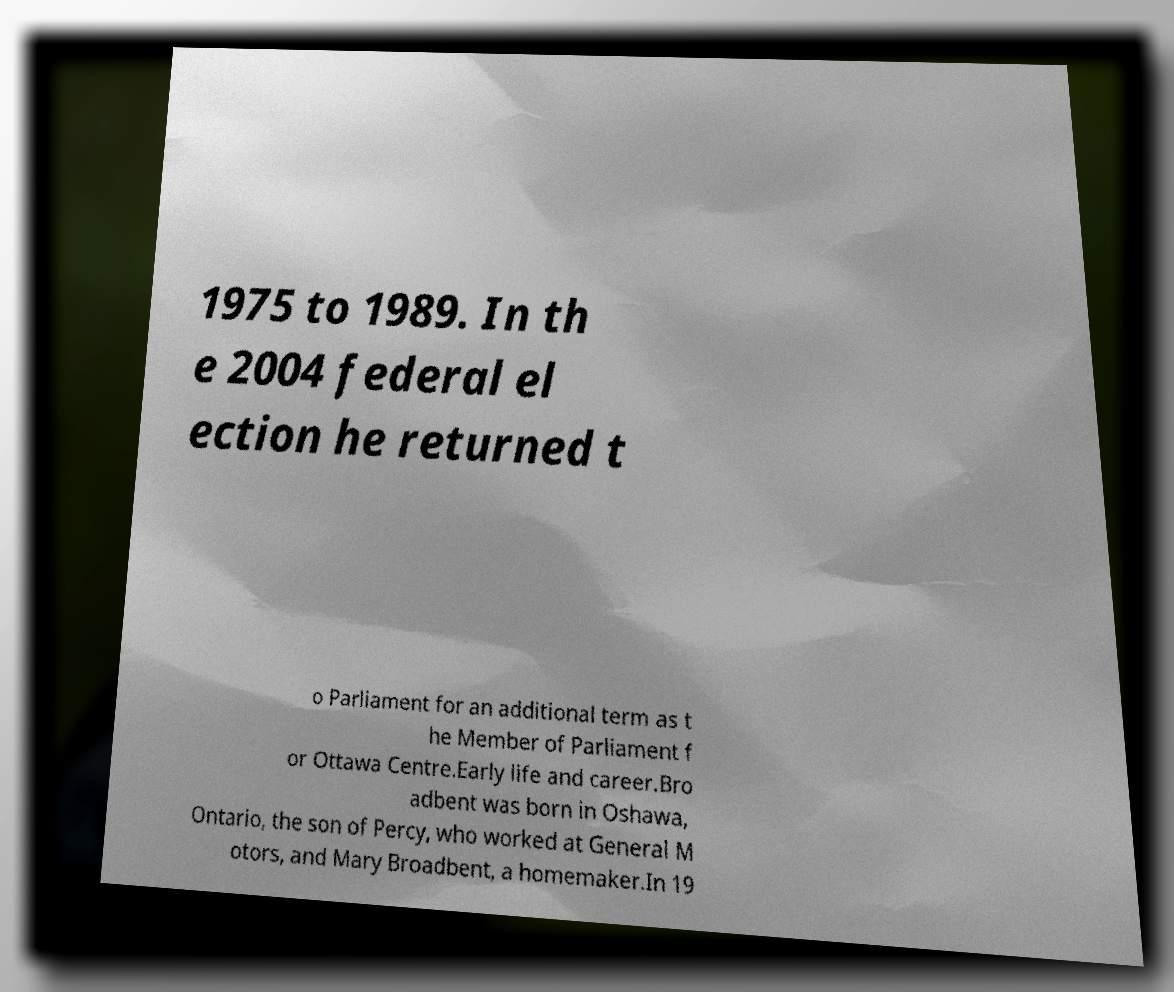For documentation purposes, I need the text within this image transcribed. Could you provide that? 1975 to 1989. In th e 2004 federal el ection he returned t o Parliament for an additional term as t he Member of Parliament f or Ottawa Centre.Early life and career.Bro adbent was born in Oshawa, Ontario, the son of Percy, who worked at General M otors, and Mary Broadbent, a homemaker.In 19 